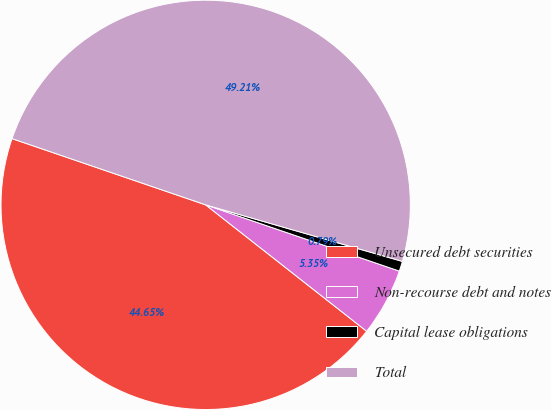<chart> <loc_0><loc_0><loc_500><loc_500><pie_chart><fcel>Unsecured debt securities<fcel>Non-recourse debt and notes<fcel>Capital lease obligations<fcel>Total<nl><fcel>44.65%<fcel>5.35%<fcel>0.79%<fcel>49.21%<nl></chart> 